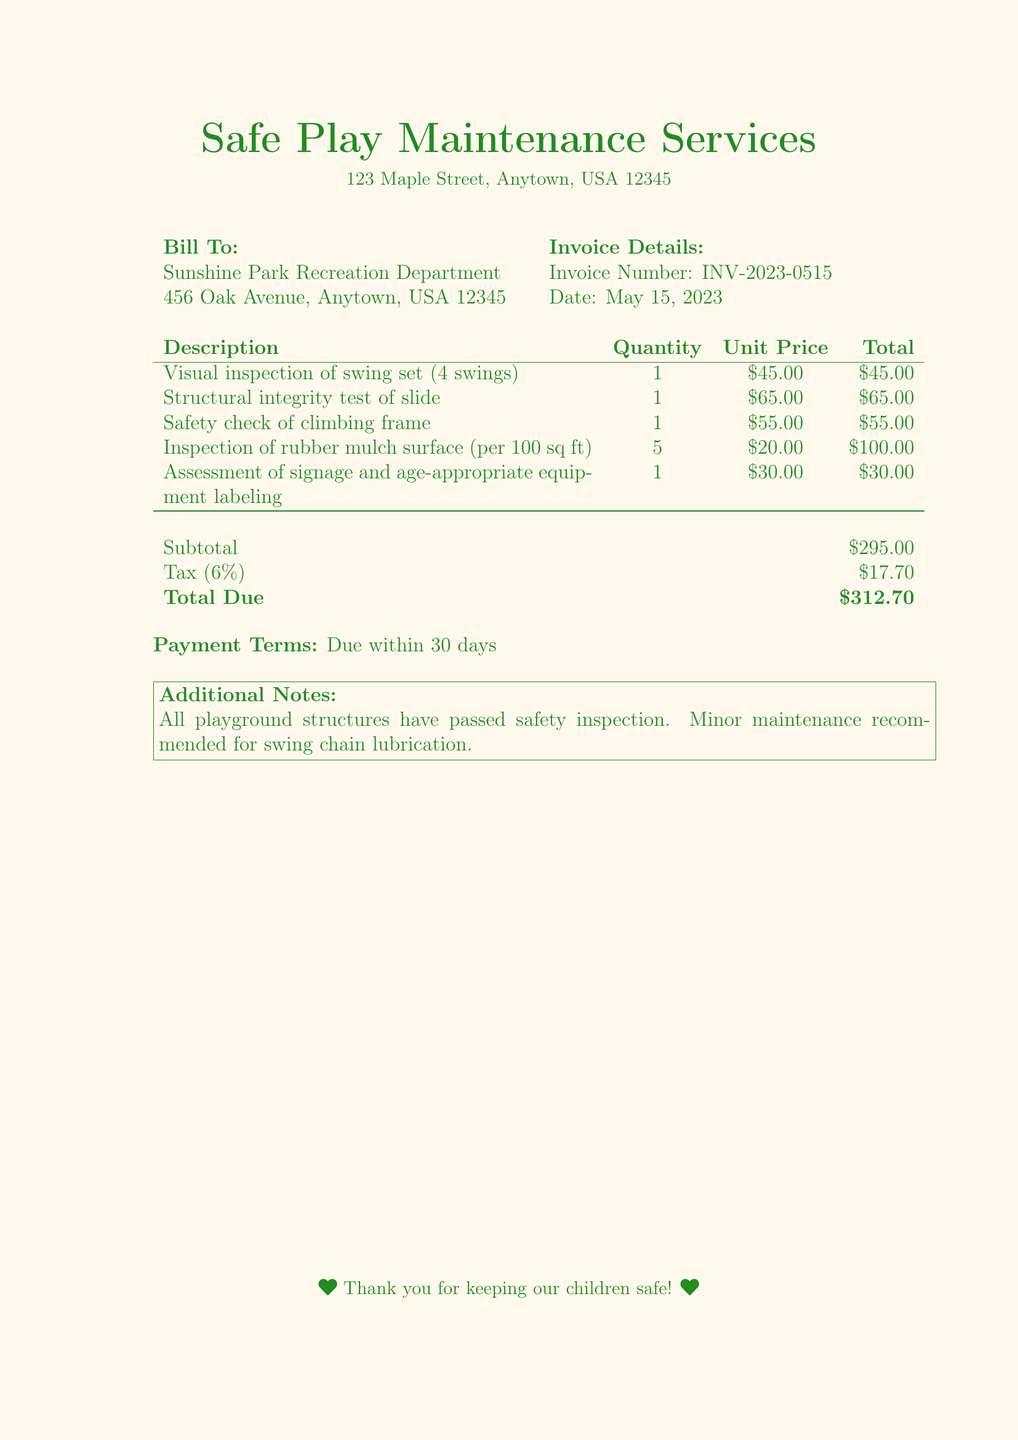what is the invoice number? The invoice number is listed at the top of the document under Invoice Details, which is INV-2023-0515.
Answer: INV-2023-0515 what is the date of the invoice? The date is specified in the Invoice Details section of the document, which is May 15, 2023.
Answer: May 15, 2023 how much was charged for the safety check of the climbing frame? The cost for the safety check of the climbing frame is given in the table under Description, which is $55.00.
Answer: $55.00 what is the total due amount? The total due amount is found at the bottom of the document, which sums all charges and tax, amounting to $312.70.
Answer: $312.70 how many swings were included in the visual inspection? The visual inspection description specifies there are 4 swings, as indicated in the table.
Answer: 4 swings what percentage tax was applied to the subtotal? The tax rate is stated as 6%, which is applied to the subtotal.
Answer: 6% what is one recommended maintenance task mentioned in the additional notes? The additional notes suggest minor maintenance for swing chain lubrication, as noted in the last part of the document.
Answer: swing chain lubrication how many square feet were assessed for the rubber mulch surface? The quantity table shows that the assessment was for 5 per 100 square feet, resulting in 500 square feet total.
Answer: 500 square feet what is the subtotal before tax? The subtotal is listed in the billing section before tax is added, which amounts to $295.00.
Answer: $295.00 